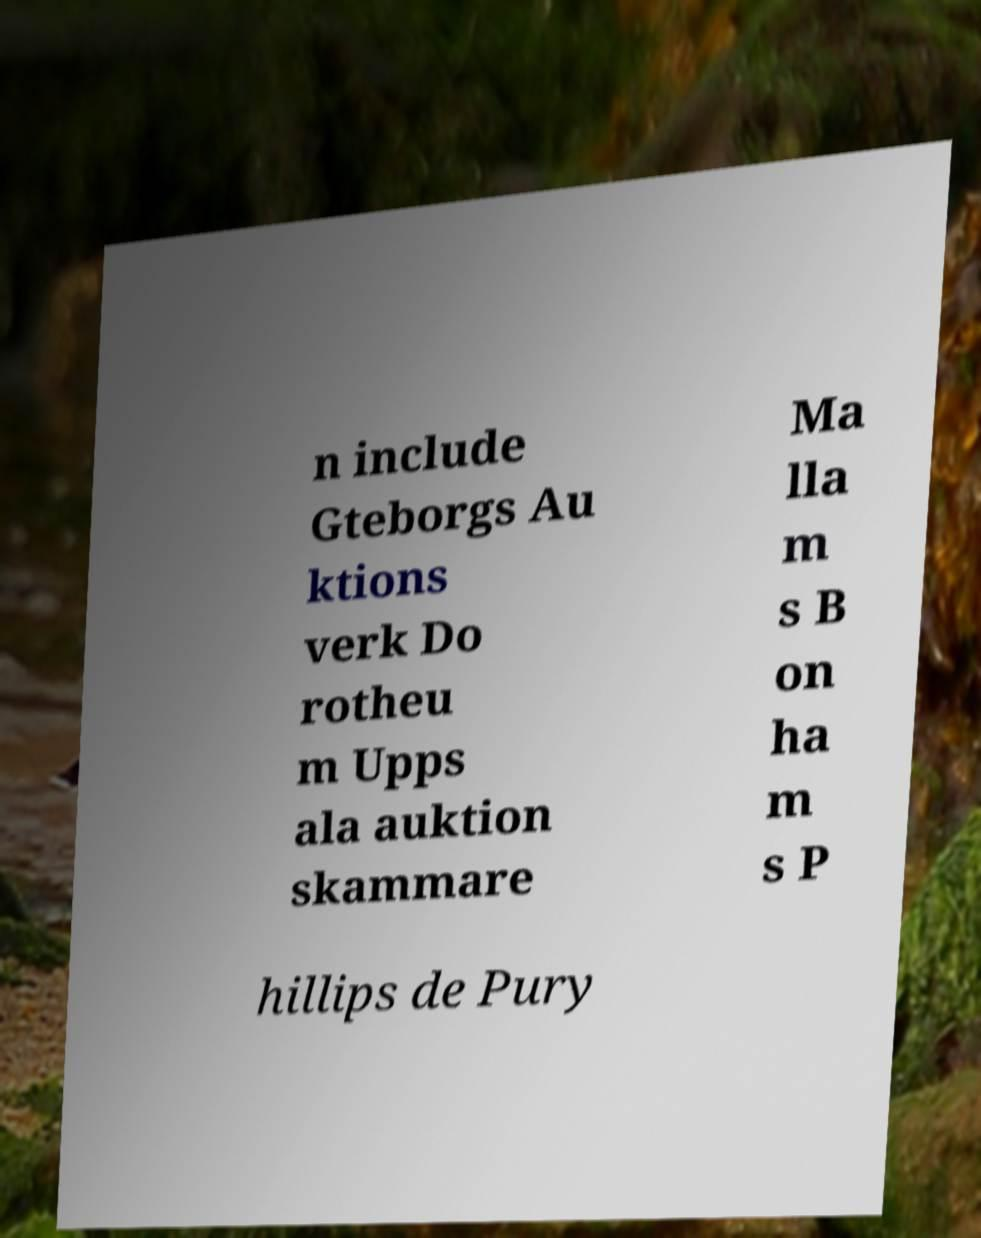Could you extract and type out the text from this image? n include Gteborgs Au ktions verk Do rotheu m Upps ala auktion skammare Ma lla m s B on ha m s P hillips de Pury 